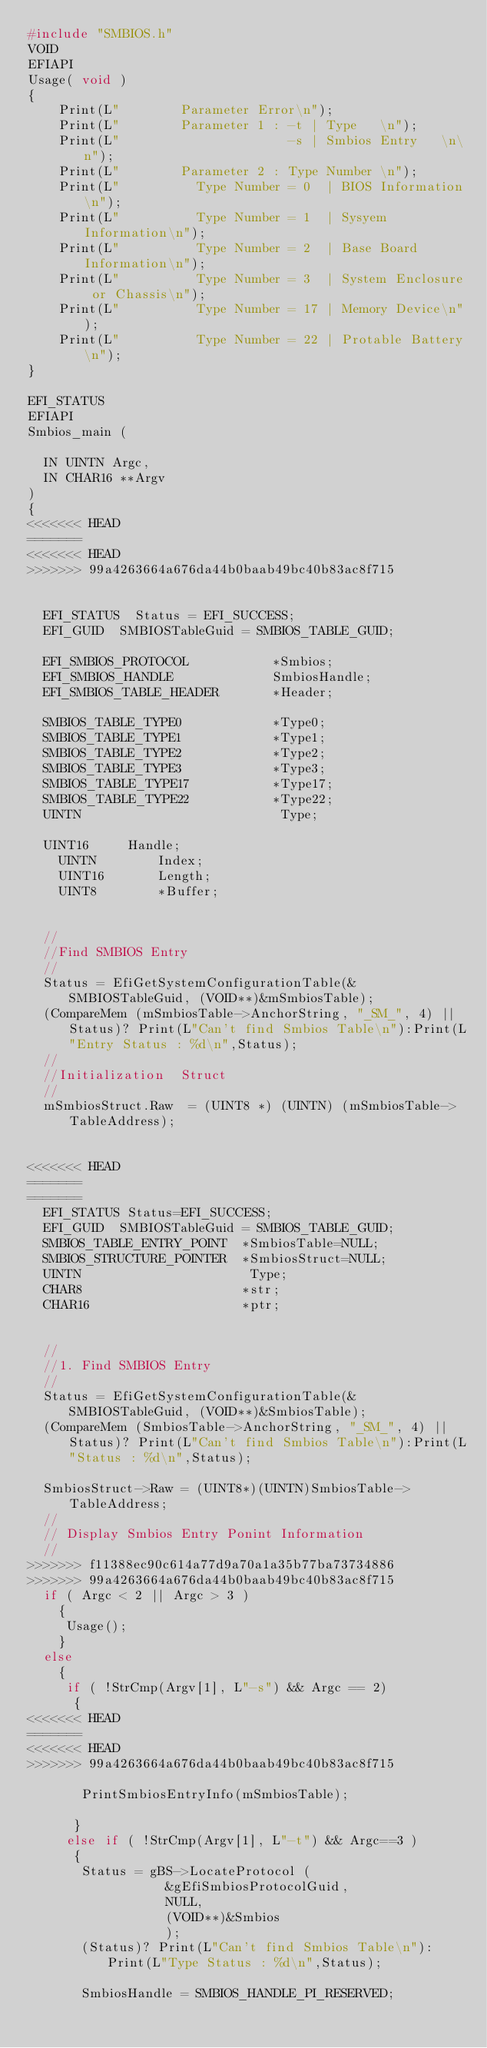<code> <loc_0><loc_0><loc_500><loc_500><_C_>#include "SMBIOS.h"
VOID
EFIAPI
Usage( void )
{
    Print(L"        Parameter Error\n");
    Print(L"        Parameter 1 : -t | Type   \n");
    Print(L"                      -s | Smbios Entry   \n\n");                              
    Print(L"        Parameter 2 : Type Number \n");
    Print(L"          Type Number = 0  | BIOS Information\n");
    Print(L"          Type Number = 1  | Sysyem Information\n");
    Print(L"          Type Number = 2  | Base Board Information\n");
    Print(L"          Type Number = 3  | System Enclosure or Chassis\n");
    Print(L"          Type Number = 17 | Memory Device\n");
    Print(L"          Type Number = 22 | Protable Battery\n");
}

EFI_STATUS
EFIAPI
Smbios_main (

  IN UINTN Argc,
  IN CHAR16 **Argv
)
{
<<<<<<< HEAD
=======
<<<<<<< HEAD
>>>>>>> 99a4263664a676da44b0baab49bc40b83ac8f715
  

  EFI_STATUS  Status = EFI_SUCCESS;
  EFI_GUID  SMBIOSTableGuid = SMBIOS_TABLE_GUID;
 
  EFI_SMBIOS_PROTOCOL           *Smbios;
  EFI_SMBIOS_HANDLE             SmbiosHandle;
  EFI_SMBIOS_TABLE_HEADER       *Header;

  SMBIOS_TABLE_TYPE0            *Type0;
  SMBIOS_TABLE_TYPE1            *Type1;
  SMBIOS_TABLE_TYPE2            *Type2;
  SMBIOS_TABLE_TYPE3            *Type3;
  SMBIOS_TABLE_TYPE17           *Type17;
  SMBIOS_TABLE_TYPE22           *Type22;
  UINTN                          Type;

  UINT16  	 Handle;
 	UINTN   	 Index;
 	UINT16  	 Length;
 	UINT8   	 *Buffer;
  
  
  //
  //Find SMBIOS Entry
  //
  Status = EfiGetSystemConfigurationTable(&SMBIOSTableGuid, (VOID**)&mSmbiosTable);
  (CompareMem (mSmbiosTable->AnchorString, "_SM_", 4) || Status)? Print(L"Can't find Smbios Table\n"):Print(L"Entry Status : %d\n",Status);
  //
  //Initialization  Struct
  //
  mSmbiosStruct.Raw  = (UINT8 *) (UINTN) (mSmbiosTable->TableAddress);
  
 
<<<<<<< HEAD
=======
=======
  EFI_STATUS Status=EFI_SUCCESS;
  EFI_GUID  SMBIOSTableGuid = SMBIOS_TABLE_GUID;
  SMBIOS_TABLE_ENTRY_POINT  *SmbiosTable=NULL;
  SMBIOS_STRUCTURE_POINTER  *SmbiosStruct=NULL;
  UINTN                      Type;
  CHAR8                     *str;
  CHAR16                    *ptr;
  
  
  //
  //1. Find SMBIOS Entry
  //
  Status = EfiGetSystemConfigurationTable(&SMBIOSTableGuid, (VOID**)&SmbiosTable);
  (CompareMem (SmbiosTable->AnchorString, "_SM_", 4) || Status)? Print(L"Can't find Smbios Table\n"):Print(L"Status : %d\n",Status);

  SmbiosStruct->Raw = (UINT8*)(UINTN)SmbiosTable->TableAddress;
  //
  // Display Smbios Entry Ponint Information
  //
>>>>>>> f11388ec90c614a77d9a70a1a35b77ba73734886
>>>>>>> 99a4263664a676da44b0baab49bc40b83ac8f715
  if ( Argc < 2 || Argc > 3 )
    {
     Usage();
    }
  else
    {
     if ( !StrCmp(Argv[1], L"-s") && Argc == 2)
      {
<<<<<<< HEAD
=======
<<<<<<< HEAD
>>>>>>> 99a4263664a676da44b0baab49bc40b83ac8f715
       
       PrintSmbiosEntryInfo(mSmbiosTable);
       
      }
     else if ( !StrCmp(Argv[1], L"-t") && Argc==3 )
      {
       Status = gBS->LocateProtocol (
                  &gEfiSmbiosProtocolGuid,
                  NULL,
                  (VOID**)&Smbios
                  );
       (Status)? Print(L"Can't find Smbios Table\n"):Print(L"Type Status : %d\n",Status);

       SmbiosHandle = SMBIOS_HANDLE_PI_RESERVED;</code> 